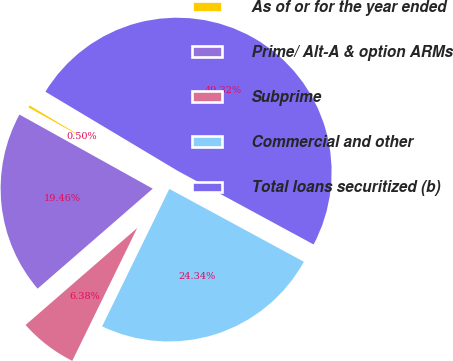Convert chart. <chart><loc_0><loc_0><loc_500><loc_500><pie_chart><fcel>As of or for the year ended<fcel>Prime/ Alt-A & option ARMs<fcel>Subprime<fcel>Commercial and other<fcel>Total loans securitized (b)<nl><fcel>0.5%<fcel>19.46%<fcel>6.38%<fcel>24.34%<fcel>49.32%<nl></chart> 